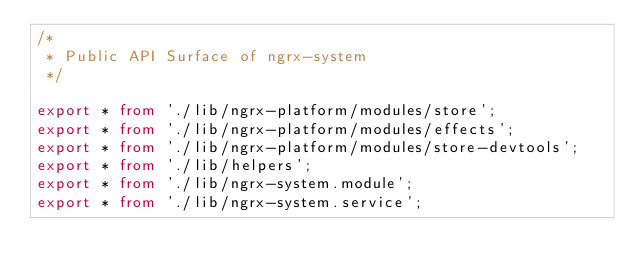Convert code to text. <code><loc_0><loc_0><loc_500><loc_500><_TypeScript_>/*
 * Public API Surface of ngrx-system
 */

export * from './lib/ngrx-platform/modules/store';
export * from './lib/ngrx-platform/modules/effects';
export * from './lib/ngrx-platform/modules/store-devtools';
export * from './lib/helpers';
export * from './lib/ngrx-system.module';
export * from './lib/ngrx-system.service';
</code> 